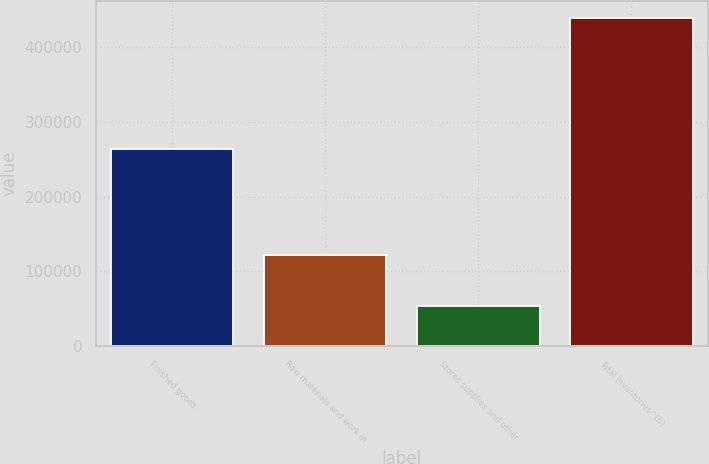<chart> <loc_0><loc_0><loc_500><loc_500><bar_chart><fcel>Finished goods<fcel>Raw materials and work in<fcel>Stores supplies and other<fcel>Total inventories^(b)<nl><fcel>264025<fcel>122038<fcel>53450<fcel>439513<nl></chart> 